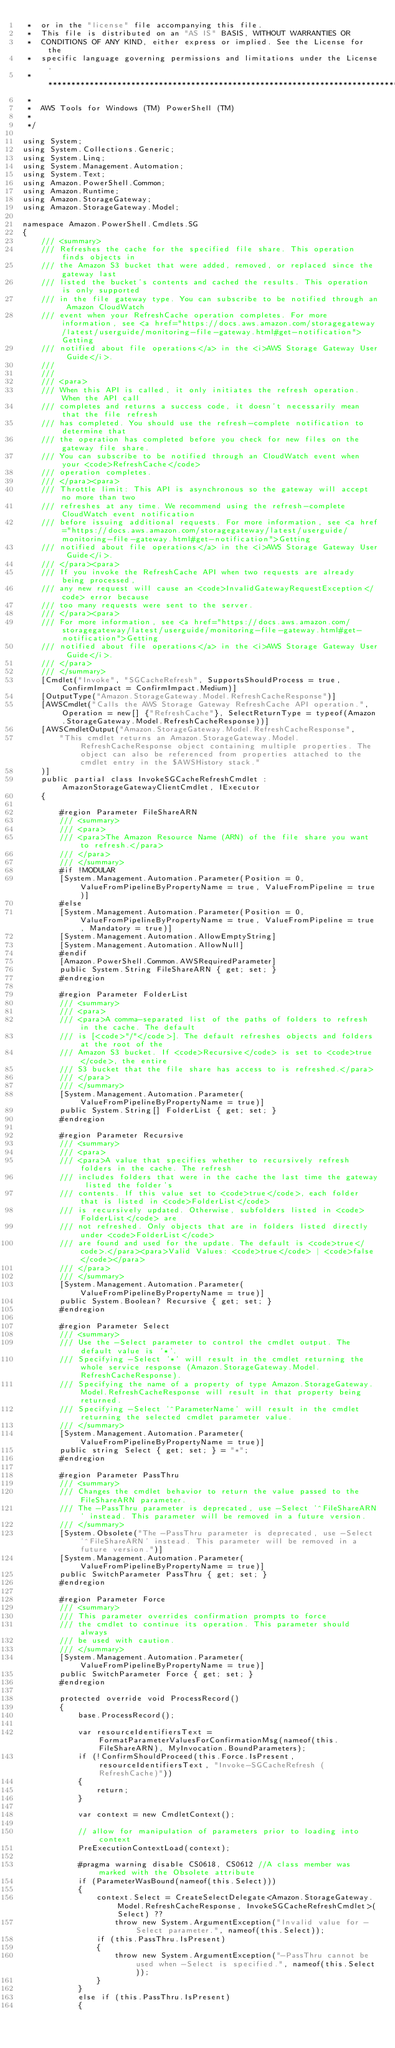Convert code to text. <code><loc_0><loc_0><loc_500><loc_500><_C#_> *  or in the "license" file accompanying this file.
 *  This file is distributed on an "AS IS" BASIS, WITHOUT WARRANTIES OR
 *  CONDITIONS OF ANY KIND, either express or implied. See the License for the
 *  specific language governing permissions and limitations under the License.
 * *****************************************************************************
 *
 *  AWS Tools for Windows (TM) PowerShell (TM)
 *
 */

using System;
using System.Collections.Generic;
using System.Linq;
using System.Management.Automation;
using System.Text;
using Amazon.PowerShell.Common;
using Amazon.Runtime;
using Amazon.StorageGateway;
using Amazon.StorageGateway.Model;

namespace Amazon.PowerShell.Cmdlets.SG
{
    /// <summary>
    /// Refreshes the cache for the specified file share. This operation finds objects in
    /// the Amazon S3 bucket that were added, removed, or replaced since the gateway last
    /// listed the bucket's contents and cached the results. This operation is only supported
    /// in the file gateway type. You can subscribe to be notified through an Amazon CloudWatch
    /// event when your RefreshCache operation completes. For more information, see <a href="https://docs.aws.amazon.com/storagegateway/latest/userguide/monitoring-file-gateway.html#get-notification">Getting
    /// notified about file operations</a> in the <i>AWS Storage Gateway User Guide</i>.
    /// 
    ///  
    /// <para>
    /// When this API is called, it only initiates the refresh operation. When the API call
    /// completes and returns a success code, it doesn't necessarily mean that the file refresh
    /// has completed. You should use the refresh-complete notification to determine that
    /// the operation has completed before you check for new files on the gateway file share.
    /// You can subscribe to be notified through an CloudWatch event when your <code>RefreshCache</code>
    /// operation completes.
    /// </para><para>
    /// Throttle limit: This API is asynchronous so the gateway will accept no more than two
    /// refreshes at any time. We recommend using the refresh-complete CloudWatch event notification
    /// before issuing additional requests. For more information, see <a href="https://docs.aws.amazon.com/storagegateway/latest/userguide/monitoring-file-gateway.html#get-notification">Getting
    /// notified about file operations</a> in the <i>AWS Storage Gateway User Guide</i>.
    /// </para><para>
    /// If you invoke the RefreshCache API when two requests are already being processed,
    /// any new request will cause an <code>InvalidGatewayRequestException</code> error because
    /// too many requests were sent to the server.
    /// </para><para>
    /// For more information, see <a href="https://docs.aws.amazon.com/storagegateway/latest/userguide/monitoring-file-gateway.html#get-notification">Getting
    /// notified about file operations</a> in the <i>AWS Storage Gateway User Guide</i>.
    /// </para>
    /// </summary>
    [Cmdlet("Invoke", "SGCacheRefresh", SupportsShouldProcess = true, ConfirmImpact = ConfirmImpact.Medium)]
    [OutputType("Amazon.StorageGateway.Model.RefreshCacheResponse")]
    [AWSCmdlet("Calls the AWS Storage Gateway RefreshCache API operation.", Operation = new[] {"RefreshCache"}, SelectReturnType = typeof(Amazon.StorageGateway.Model.RefreshCacheResponse))]
    [AWSCmdletOutput("Amazon.StorageGateway.Model.RefreshCacheResponse",
        "This cmdlet returns an Amazon.StorageGateway.Model.RefreshCacheResponse object containing multiple properties. The object can also be referenced from properties attached to the cmdlet entry in the $AWSHistory stack."
    )]
    public partial class InvokeSGCacheRefreshCmdlet : AmazonStorageGatewayClientCmdlet, IExecutor
    {
        
        #region Parameter FileShareARN
        /// <summary>
        /// <para>
        /// <para>The Amazon Resource Name (ARN) of the file share you want to refresh.</para>
        /// </para>
        /// </summary>
        #if !MODULAR
        [System.Management.Automation.Parameter(Position = 0, ValueFromPipelineByPropertyName = true, ValueFromPipeline = true)]
        #else
        [System.Management.Automation.Parameter(Position = 0, ValueFromPipelineByPropertyName = true, ValueFromPipeline = true, Mandatory = true)]
        [System.Management.Automation.AllowEmptyString]
        [System.Management.Automation.AllowNull]
        #endif
        [Amazon.PowerShell.Common.AWSRequiredParameter]
        public System.String FileShareARN { get; set; }
        #endregion
        
        #region Parameter FolderList
        /// <summary>
        /// <para>
        /// <para>A comma-separated list of the paths of folders to refresh in the cache. The default
        /// is [<code>"/"</code>]. The default refreshes objects and folders at the root of the
        /// Amazon S3 bucket. If <code>Recursive</code> is set to <code>true</code>, the entire
        /// S3 bucket that the file share has access to is refreshed.</para>
        /// </para>
        /// </summary>
        [System.Management.Automation.Parameter(ValueFromPipelineByPropertyName = true)]
        public System.String[] FolderList { get; set; }
        #endregion
        
        #region Parameter Recursive
        /// <summary>
        /// <para>
        /// <para>A value that specifies whether to recursively refresh folders in the cache. The refresh
        /// includes folders that were in the cache the last time the gateway listed the folder's
        /// contents. If this value set to <code>true</code>, each folder that is listed in <code>FolderList</code>
        /// is recursively updated. Otherwise, subfolders listed in <code>FolderList</code> are
        /// not refreshed. Only objects that are in folders listed directly under <code>FolderList</code>
        /// are found and used for the update. The default is <code>true</code>.</para><para>Valid Values: <code>true</code> | <code>false</code></para>
        /// </para>
        /// </summary>
        [System.Management.Automation.Parameter(ValueFromPipelineByPropertyName = true)]
        public System.Boolean? Recursive { get; set; }
        #endregion
        
        #region Parameter Select
        /// <summary>
        /// Use the -Select parameter to control the cmdlet output. The default value is '*'.
        /// Specifying -Select '*' will result in the cmdlet returning the whole service response (Amazon.StorageGateway.Model.RefreshCacheResponse).
        /// Specifying the name of a property of type Amazon.StorageGateway.Model.RefreshCacheResponse will result in that property being returned.
        /// Specifying -Select '^ParameterName' will result in the cmdlet returning the selected cmdlet parameter value.
        /// </summary>
        [System.Management.Automation.Parameter(ValueFromPipelineByPropertyName = true)]
        public string Select { get; set; } = "*";
        #endregion
        
        #region Parameter PassThru
        /// <summary>
        /// Changes the cmdlet behavior to return the value passed to the FileShareARN parameter.
        /// The -PassThru parameter is deprecated, use -Select '^FileShareARN' instead. This parameter will be removed in a future version.
        /// </summary>
        [System.Obsolete("The -PassThru parameter is deprecated, use -Select '^FileShareARN' instead. This parameter will be removed in a future version.")]
        [System.Management.Automation.Parameter(ValueFromPipelineByPropertyName = true)]
        public SwitchParameter PassThru { get; set; }
        #endregion
        
        #region Parameter Force
        /// <summary>
        /// This parameter overrides confirmation prompts to force 
        /// the cmdlet to continue its operation. This parameter should always
        /// be used with caution.
        /// </summary>
        [System.Management.Automation.Parameter(ValueFromPipelineByPropertyName = true)]
        public SwitchParameter Force { get; set; }
        #endregion
        
        protected override void ProcessRecord()
        {
            base.ProcessRecord();
            
            var resourceIdentifiersText = FormatParameterValuesForConfirmationMsg(nameof(this.FileShareARN), MyInvocation.BoundParameters);
            if (!ConfirmShouldProceed(this.Force.IsPresent, resourceIdentifiersText, "Invoke-SGCacheRefresh (RefreshCache)"))
            {
                return;
            }
            
            var context = new CmdletContext();
            
            // allow for manipulation of parameters prior to loading into context
            PreExecutionContextLoad(context);
            
            #pragma warning disable CS0618, CS0612 //A class member was marked with the Obsolete attribute
            if (ParameterWasBound(nameof(this.Select)))
            {
                context.Select = CreateSelectDelegate<Amazon.StorageGateway.Model.RefreshCacheResponse, InvokeSGCacheRefreshCmdlet>(Select) ??
                    throw new System.ArgumentException("Invalid value for -Select parameter.", nameof(this.Select));
                if (this.PassThru.IsPresent)
                {
                    throw new System.ArgumentException("-PassThru cannot be used when -Select is specified.", nameof(this.Select));
                }
            }
            else if (this.PassThru.IsPresent)
            {</code> 